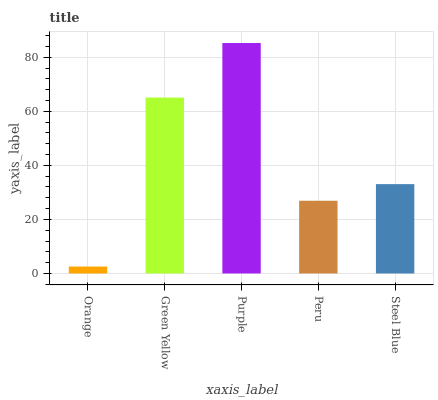Is Orange the minimum?
Answer yes or no. Yes. Is Purple the maximum?
Answer yes or no. Yes. Is Green Yellow the minimum?
Answer yes or no. No. Is Green Yellow the maximum?
Answer yes or no. No. Is Green Yellow greater than Orange?
Answer yes or no. Yes. Is Orange less than Green Yellow?
Answer yes or no. Yes. Is Orange greater than Green Yellow?
Answer yes or no. No. Is Green Yellow less than Orange?
Answer yes or no. No. Is Steel Blue the high median?
Answer yes or no. Yes. Is Steel Blue the low median?
Answer yes or no. Yes. Is Purple the high median?
Answer yes or no. No. Is Peru the low median?
Answer yes or no. No. 